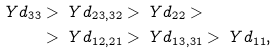<formula> <loc_0><loc_0><loc_500><loc_500>\ Y d _ { 3 3 } & > \ Y d _ { 2 3 , 3 2 } > \ Y d _ { 2 2 } > \\ & > \ Y d _ { 1 2 , 2 1 } > \ Y d _ { 1 3 , 3 1 } > \ Y d _ { 1 1 } ,</formula> 